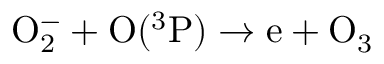<formula> <loc_0><loc_0><loc_500><loc_500>\mathrm O _ { 2 } ^ { - } + \mathrm O ( ^ { 3 } \mathrm P ) \to \mathrm e + \mathrm O _ { 3 }</formula> 